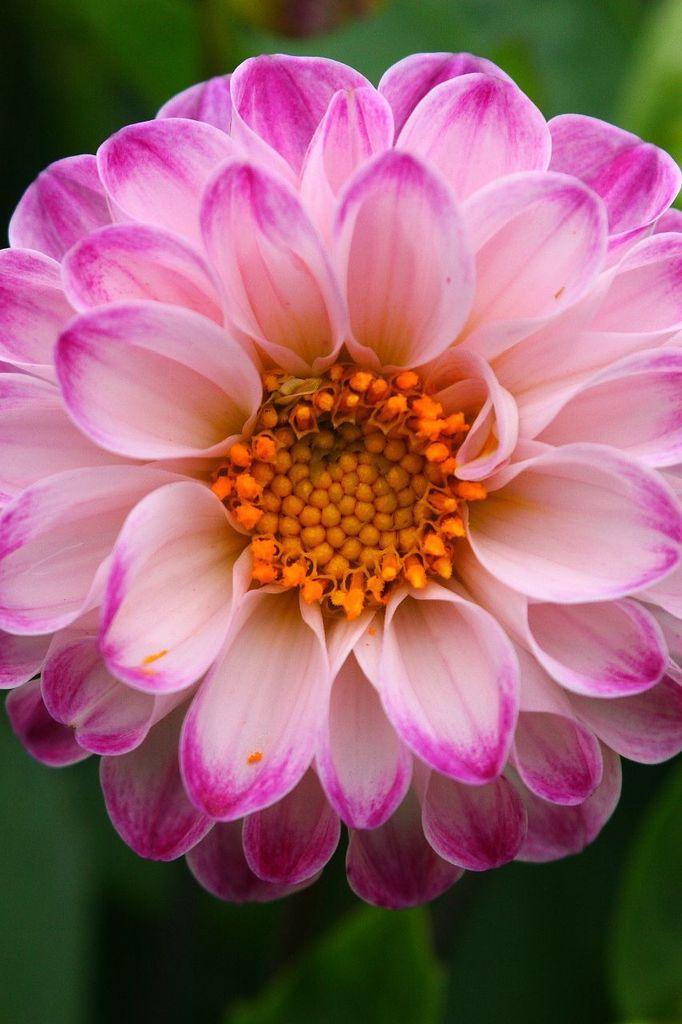Can you describe this image briefly? In this image we can see a flower and we can also see the green background. 